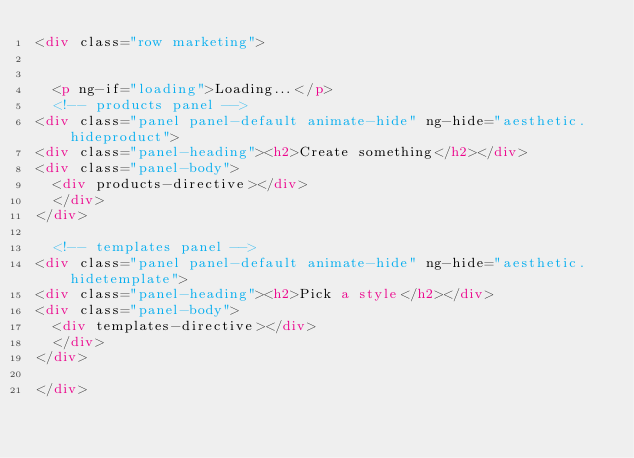<code> <loc_0><loc_0><loc_500><loc_500><_HTML_><div class="row marketing">


  <p ng-if="loading">Loading...</p>
  <!-- products panel -->
<div class="panel panel-default animate-hide" ng-hide="aesthetic.hideproduct">
<div class="panel-heading"><h2>Create something</h2></div>
<div class="panel-body">
  <div products-directive></div>
  </div>
</div>

  <!-- templates panel -->
<div class="panel panel-default animate-hide" ng-hide="aesthetic.hidetemplate">
<div class="panel-heading"><h2>Pick a style</h2></div>
<div class="panel-body">
  <div templates-directive></div>
  </div>
</div>

</div>
</code> 